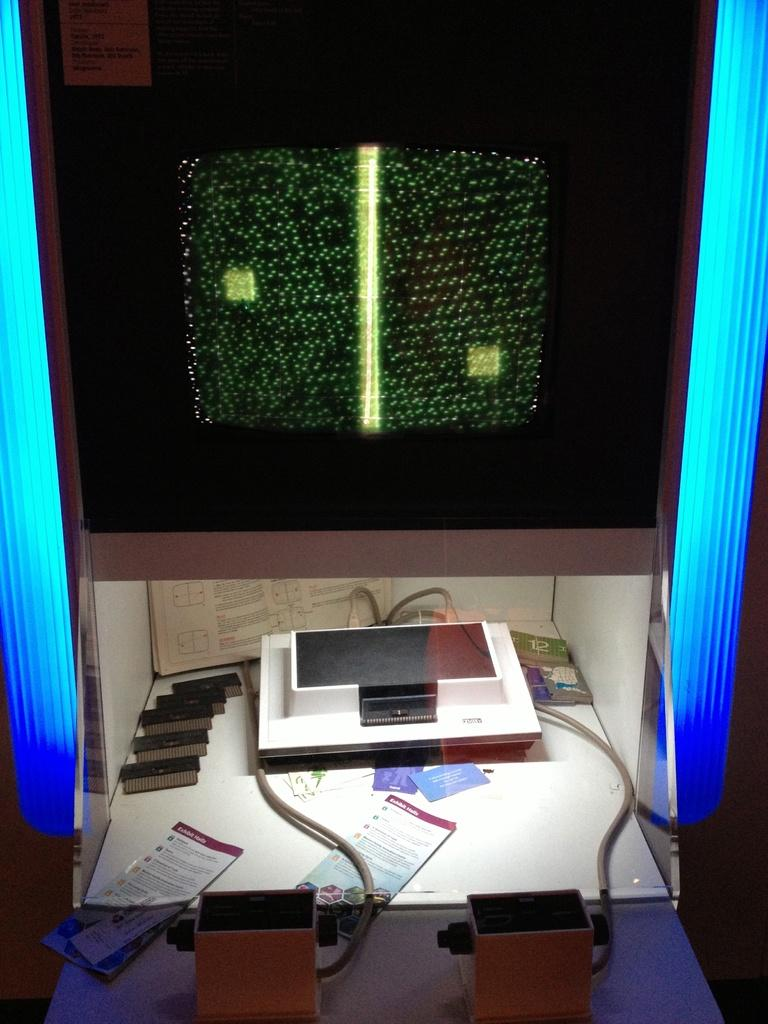Where is the television located in the image? The television is in a cupboard in the image. What other electronic devices can be seen in the image? There are electronic devices visible in the image. What can be observed about the cables in the image? Cables are visible in the image. What is present on the table in the image? Papers and a book are on the table in the image. What can be seen in the background of the image? There are lights visible in the background of the image. Who is the actor playing the main character in the image? There is no actor or main character present in the image, as it is a still photograph of a room with electronic devices and other items. 